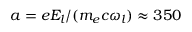<formula> <loc_0><loc_0><loc_500><loc_500>a = e E _ { l } / ( m _ { e } c \omega _ { l } ) \approx 3 5 0</formula> 